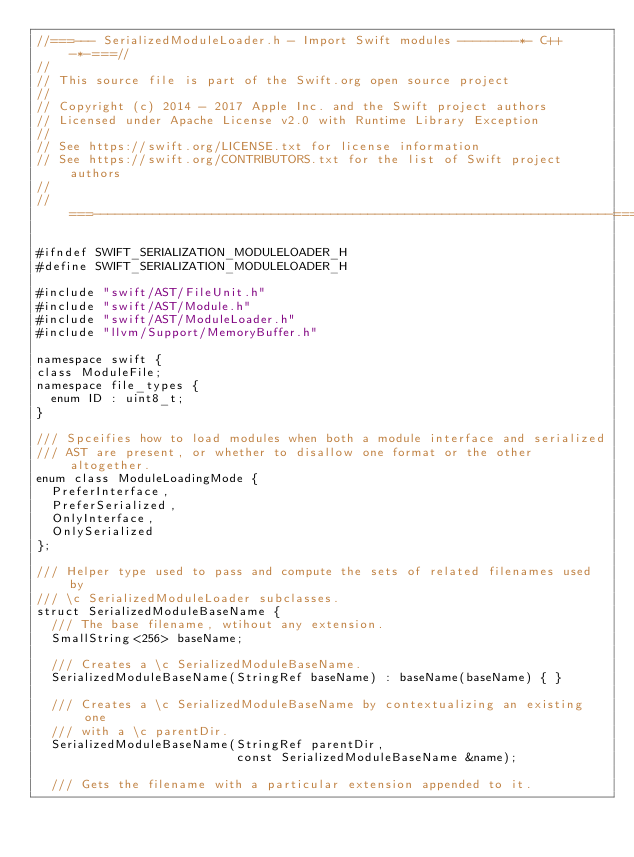<code> <loc_0><loc_0><loc_500><loc_500><_C_>//===--- SerializedModuleLoader.h - Import Swift modules --------*- C++ -*-===//
//
// This source file is part of the Swift.org open source project
//
// Copyright (c) 2014 - 2017 Apple Inc. and the Swift project authors
// Licensed under Apache License v2.0 with Runtime Library Exception
//
// See https://swift.org/LICENSE.txt for license information
// See https://swift.org/CONTRIBUTORS.txt for the list of Swift project authors
//
//===----------------------------------------------------------------------===//

#ifndef SWIFT_SERIALIZATION_MODULELOADER_H
#define SWIFT_SERIALIZATION_MODULELOADER_H

#include "swift/AST/FileUnit.h"
#include "swift/AST/Module.h"
#include "swift/AST/ModuleLoader.h"
#include "llvm/Support/MemoryBuffer.h"

namespace swift {
class ModuleFile;
namespace file_types {
  enum ID : uint8_t;
}

/// Spceifies how to load modules when both a module interface and serialized
/// AST are present, or whether to disallow one format or the other altogether.
enum class ModuleLoadingMode {
  PreferInterface,
  PreferSerialized,
  OnlyInterface,
  OnlySerialized
};

/// Helper type used to pass and compute the sets of related filenames used by
/// \c SerializedModuleLoader subclasses.
struct SerializedModuleBaseName {
  /// The base filename, wtihout any extension.
  SmallString<256> baseName;

  /// Creates a \c SerializedModuleBaseName.
  SerializedModuleBaseName(StringRef baseName) : baseName(baseName) { }

  /// Creates a \c SerializedModuleBaseName by contextualizing an existing one
  /// with a \c parentDir.
  SerializedModuleBaseName(StringRef parentDir,
                           const SerializedModuleBaseName &name);

  /// Gets the filename with a particular extension appended to it.</code> 